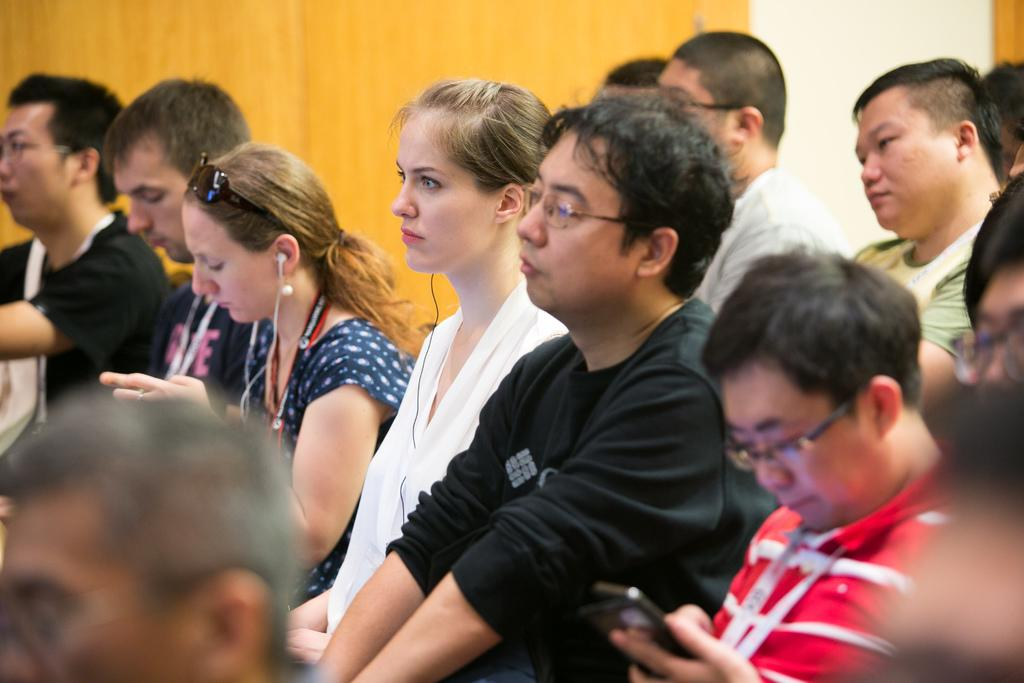What are the people in the image doing? The people in the image are sitting. What objects are some of the people holding? Some of the people are holding mobiles. What can be seen in the background of the image? There is a wall in the background of the image. How many ducks are visible in the image? There are no ducks present in the image. What channel are the people watching on their mobiles in the image? The image does not provide information about the channels being watched on the mobiles. 